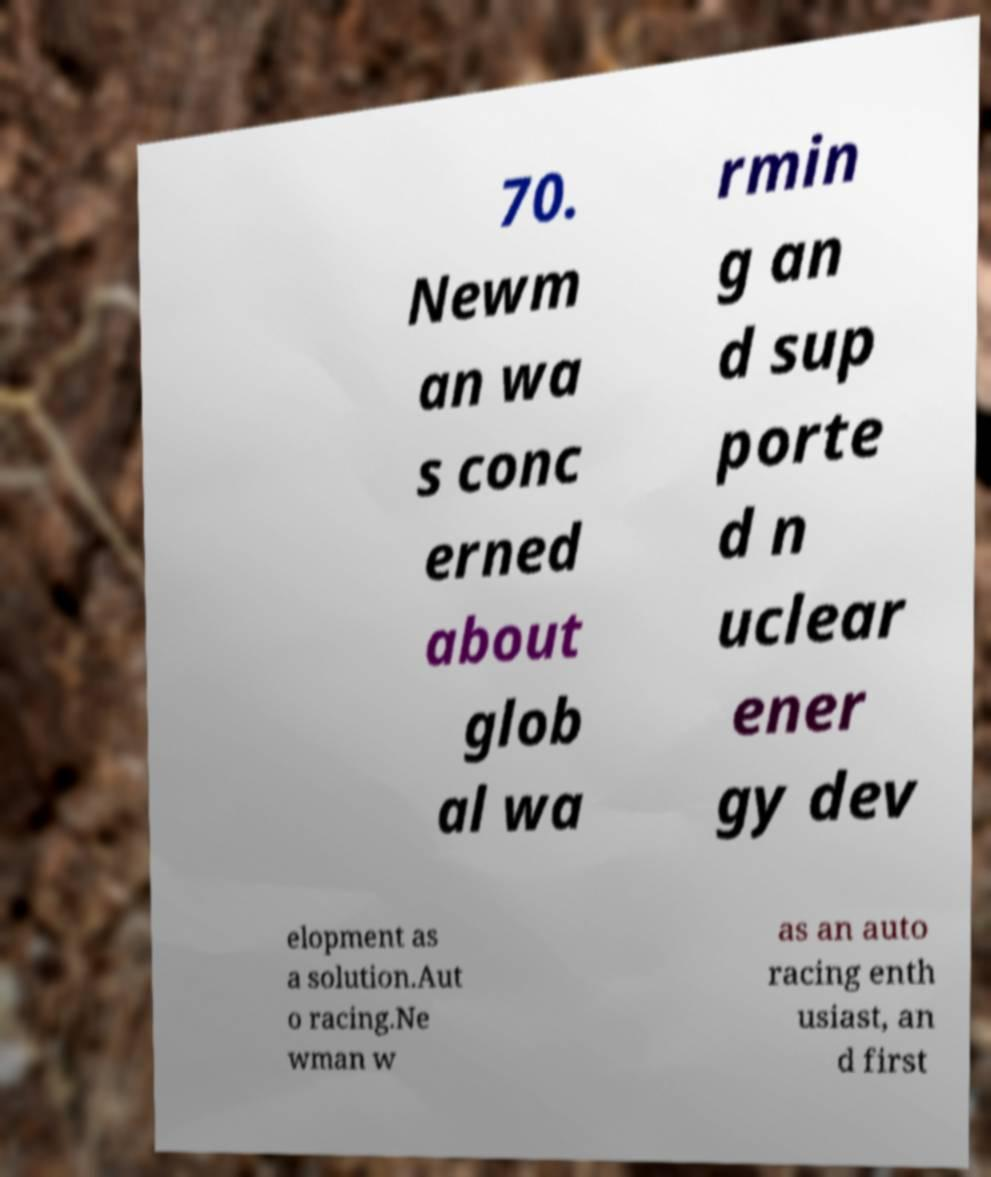Please identify and transcribe the text found in this image. 70. Newm an wa s conc erned about glob al wa rmin g an d sup porte d n uclear ener gy dev elopment as a solution.Aut o racing.Ne wman w as an auto racing enth usiast, an d first 